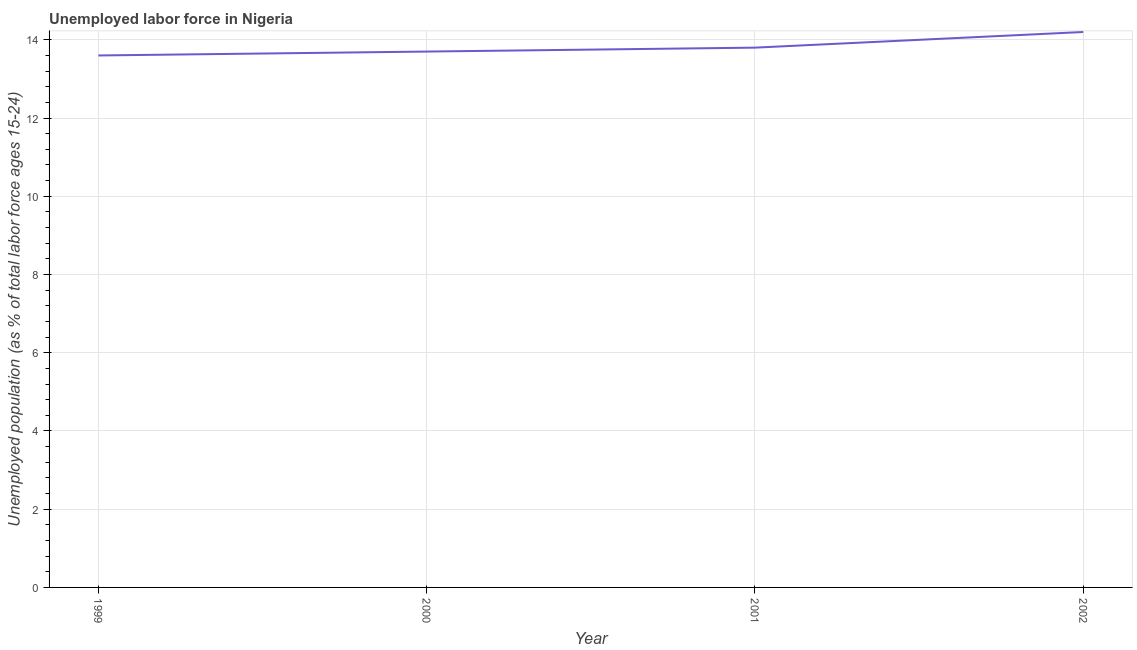What is the total unemployed youth population in 2002?
Your response must be concise. 14.2. Across all years, what is the maximum total unemployed youth population?
Your answer should be very brief. 14.2. Across all years, what is the minimum total unemployed youth population?
Make the answer very short. 13.6. In which year was the total unemployed youth population maximum?
Keep it short and to the point. 2002. What is the sum of the total unemployed youth population?
Provide a succinct answer. 55.3. What is the difference between the total unemployed youth population in 1999 and 2001?
Give a very brief answer. -0.2. What is the average total unemployed youth population per year?
Your answer should be very brief. 13.83. What is the median total unemployed youth population?
Provide a short and direct response. 13.75. In how many years, is the total unemployed youth population greater than 10.8 %?
Your answer should be compact. 4. Do a majority of the years between 2000 and 2002 (inclusive) have total unemployed youth population greater than 10 %?
Give a very brief answer. Yes. What is the ratio of the total unemployed youth population in 2000 to that in 2001?
Keep it short and to the point. 0.99. Is the difference between the total unemployed youth population in 1999 and 2001 greater than the difference between any two years?
Your answer should be very brief. No. What is the difference between the highest and the second highest total unemployed youth population?
Provide a short and direct response. 0.4. What is the difference between the highest and the lowest total unemployed youth population?
Give a very brief answer. 0.6. Does the total unemployed youth population monotonically increase over the years?
Keep it short and to the point. Yes. Does the graph contain any zero values?
Offer a very short reply. No. What is the title of the graph?
Provide a short and direct response. Unemployed labor force in Nigeria. What is the label or title of the Y-axis?
Your answer should be compact. Unemployed population (as % of total labor force ages 15-24). What is the Unemployed population (as % of total labor force ages 15-24) in 1999?
Make the answer very short. 13.6. What is the Unemployed population (as % of total labor force ages 15-24) of 2000?
Your answer should be very brief. 13.7. What is the Unemployed population (as % of total labor force ages 15-24) of 2001?
Your answer should be very brief. 13.8. What is the Unemployed population (as % of total labor force ages 15-24) of 2002?
Ensure brevity in your answer.  14.2. What is the difference between the Unemployed population (as % of total labor force ages 15-24) in 1999 and 2000?
Offer a very short reply. -0.1. What is the difference between the Unemployed population (as % of total labor force ages 15-24) in 1999 and 2001?
Offer a terse response. -0.2. What is the difference between the Unemployed population (as % of total labor force ages 15-24) in 1999 and 2002?
Provide a short and direct response. -0.6. What is the difference between the Unemployed population (as % of total labor force ages 15-24) in 2001 and 2002?
Keep it short and to the point. -0.4. What is the ratio of the Unemployed population (as % of total labor force ages 15-24) in 1999 to that in 2000?
Make the answer very short. 0.99. What is the ratio of the Unemployed population (as % of total labor force ages 15-24) in 1999 to that in 2001?
Give a very brief answer. 0.99. What is the ratio of the Unemployed population (as % of total labor force ages 15-24) in 1999 to that in 2002?
Make the answer very short. 0.96. What is the ratio of the Unemployed population (as % of total labor force ages 15-24) in 2000 to that in 2001?
Your answer should be compact. 0.99. 